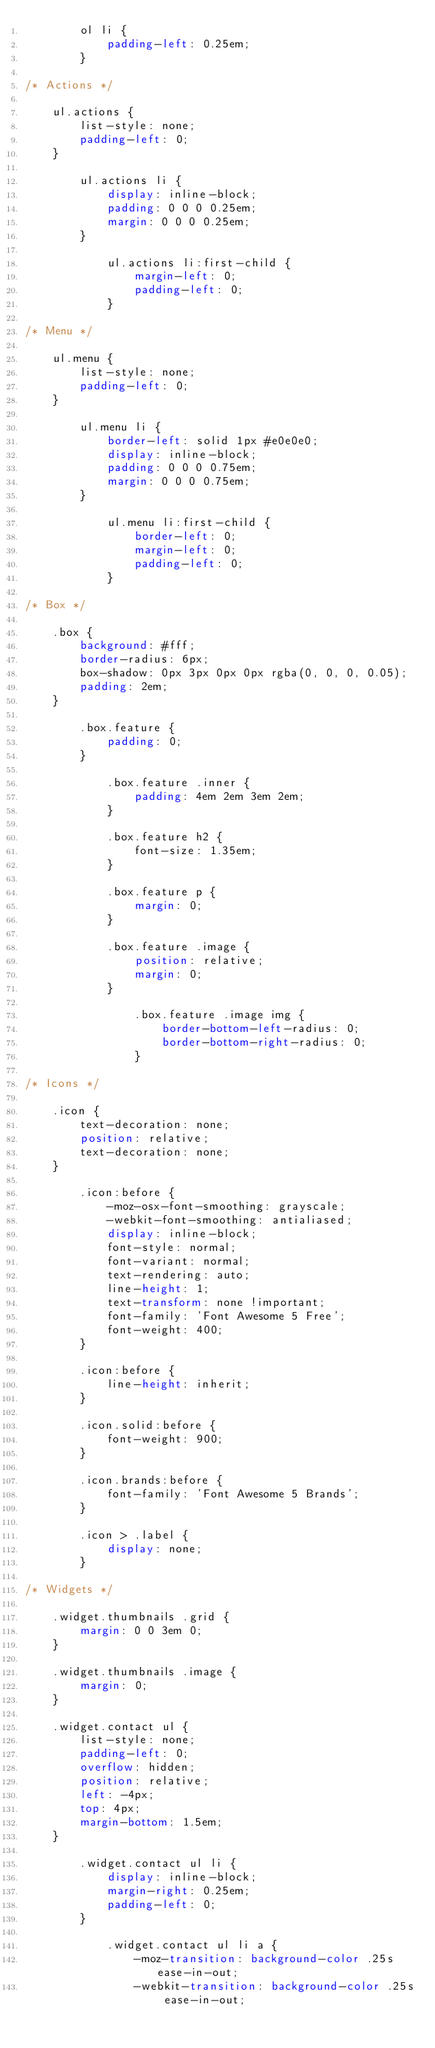Convert code to text. <code><loc_0><loc_0><loc_500><loc_500><_CSS_>		ol li {
			padding-left: 0.25em;
		}

/* Actions */

	ul.actions {
		list-style: none;
		padding-left: 0;
	}

		ul.actions li {
			display: inline-block;
			padding: 0 0 0 0.25em;
			margin: 0 0 0 0.25em;
		}

			ul.actions li:first-child {
				margin-left: 0;
				padding-left: 0;
			}

/* Menu */

	ul.menu {
		list-style: none;
		padding-left: 0;
	}

		ul.menu li {
			border-left: solid 1px #e0e0e0;
			display: inline-block;
			padding: 0 0 0 0.75em;
			margin: 0 0 0 0.75em;
		}

			ul.menu li:first-child {
				border-left: 0;
				margin-left: 0;
				padding-left: 0;
			}

/* Box */

	.box {
		background: #fff;
		border-radius: 6px;
		box-shadow: 0px 3px 0px 0px rgba(0, 0, 0, 0.05);
		padding: 2em;
	}

		.box.feature {
			padding: 0;
		}

			.box.feature .inner {
				padding: 4em 2em 3em 2em;
			}

			.box.feature h2 {
				font-size: 1.35em;
			}

			.box.feature p {
				margin: 0;
			}

			.box.feature .image {
				position: relative;
				margin: 0;
			}

				.box.feature .image img {
					border-bottom-left-radius: 0;
					border-bottom-right-radius: 0;
				}

/* Icons */

	.icon {
		text-decoration: none;
		position: relative;
		text-decoration: none;
	}

		.icon:before {
			-moz-osx-font-smoothing: grayscale;
			-webkit-font-smoothing: antialiased;
			display: inline-block;
			font-style: normal;
			font-variant: normal;
			text-rendering: auto;
			line-height: 1;
			text-transform: none !important;
			font-family: 'Font Awesome 5 Free';
			font-weight: 400;
		}

		.icon:before {
			line-height: inherit;
		}

		.icon.solid:before {
			font-weight: 900;
		}

		.icon.brands:before {
			font-family: 'Font Awesome 5 Brands';
		}

		.icon > .label {
			display: none;
		}

/* Widgets */

	.widget.thumbnails .grid {
		margin: 0 0 3em 0;
	}

	.widget.thumbnails .image {
		margin: 0;
	}

	.widget.contact ul {
		list-style: none;
		padding-left: 0;
		overflow: hidden;
		position: relative;
		left: -4px;
		top: 4px;
		margin-bottom: 1.5em;
	}

		.widget.contact ul li {
			display: inline-block;
			margin-right: 0.25em;
			padding-left: 0;
		}

			.widget.contact ul li a {
				-moz-transition: background-color .25s ease-in-out;
				-webkit-transition: background-color .25s ease-in-out;</code> 